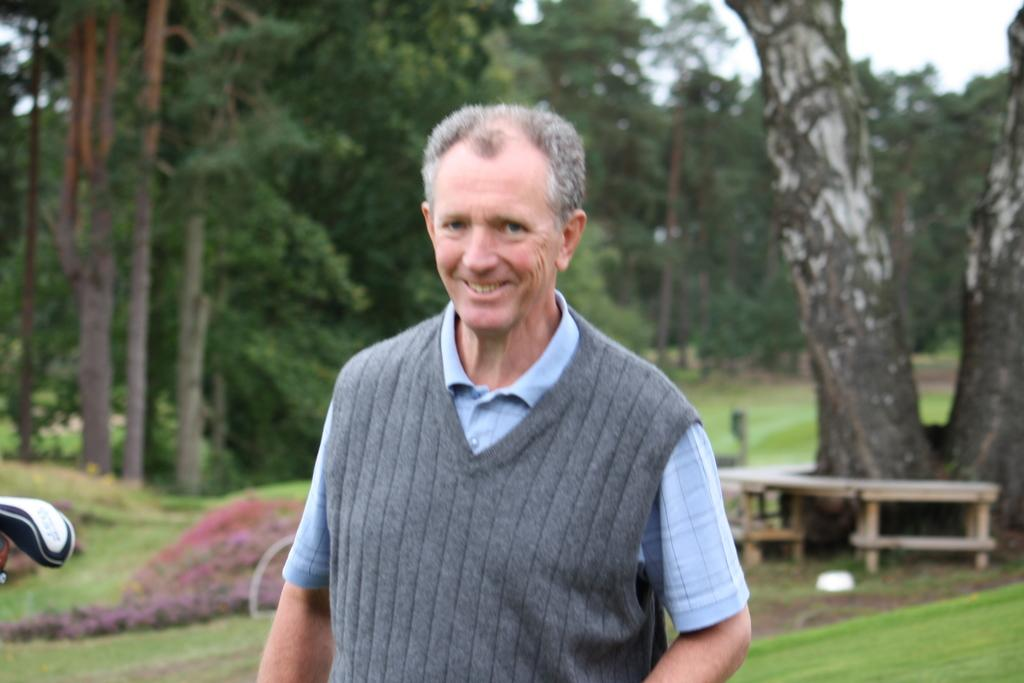Who is present in the image? There is a man in the image. What is the man's facial expression? The man is smiling. What is the primary object in the image? There is a table in the image. What type of vegetation is visible in the image? There is a tree and grass on the ground in the image. What can be seen in the background of the image? There are trees in the background of the image. What type of wax is being used to create the man's coat in the image? There is no wax or coat present in the image; the man is simply smiling. What type of fruit is being served on the table in the image? There is no fruit visible on the table in the image; only a man, a table, and a tree are present. 